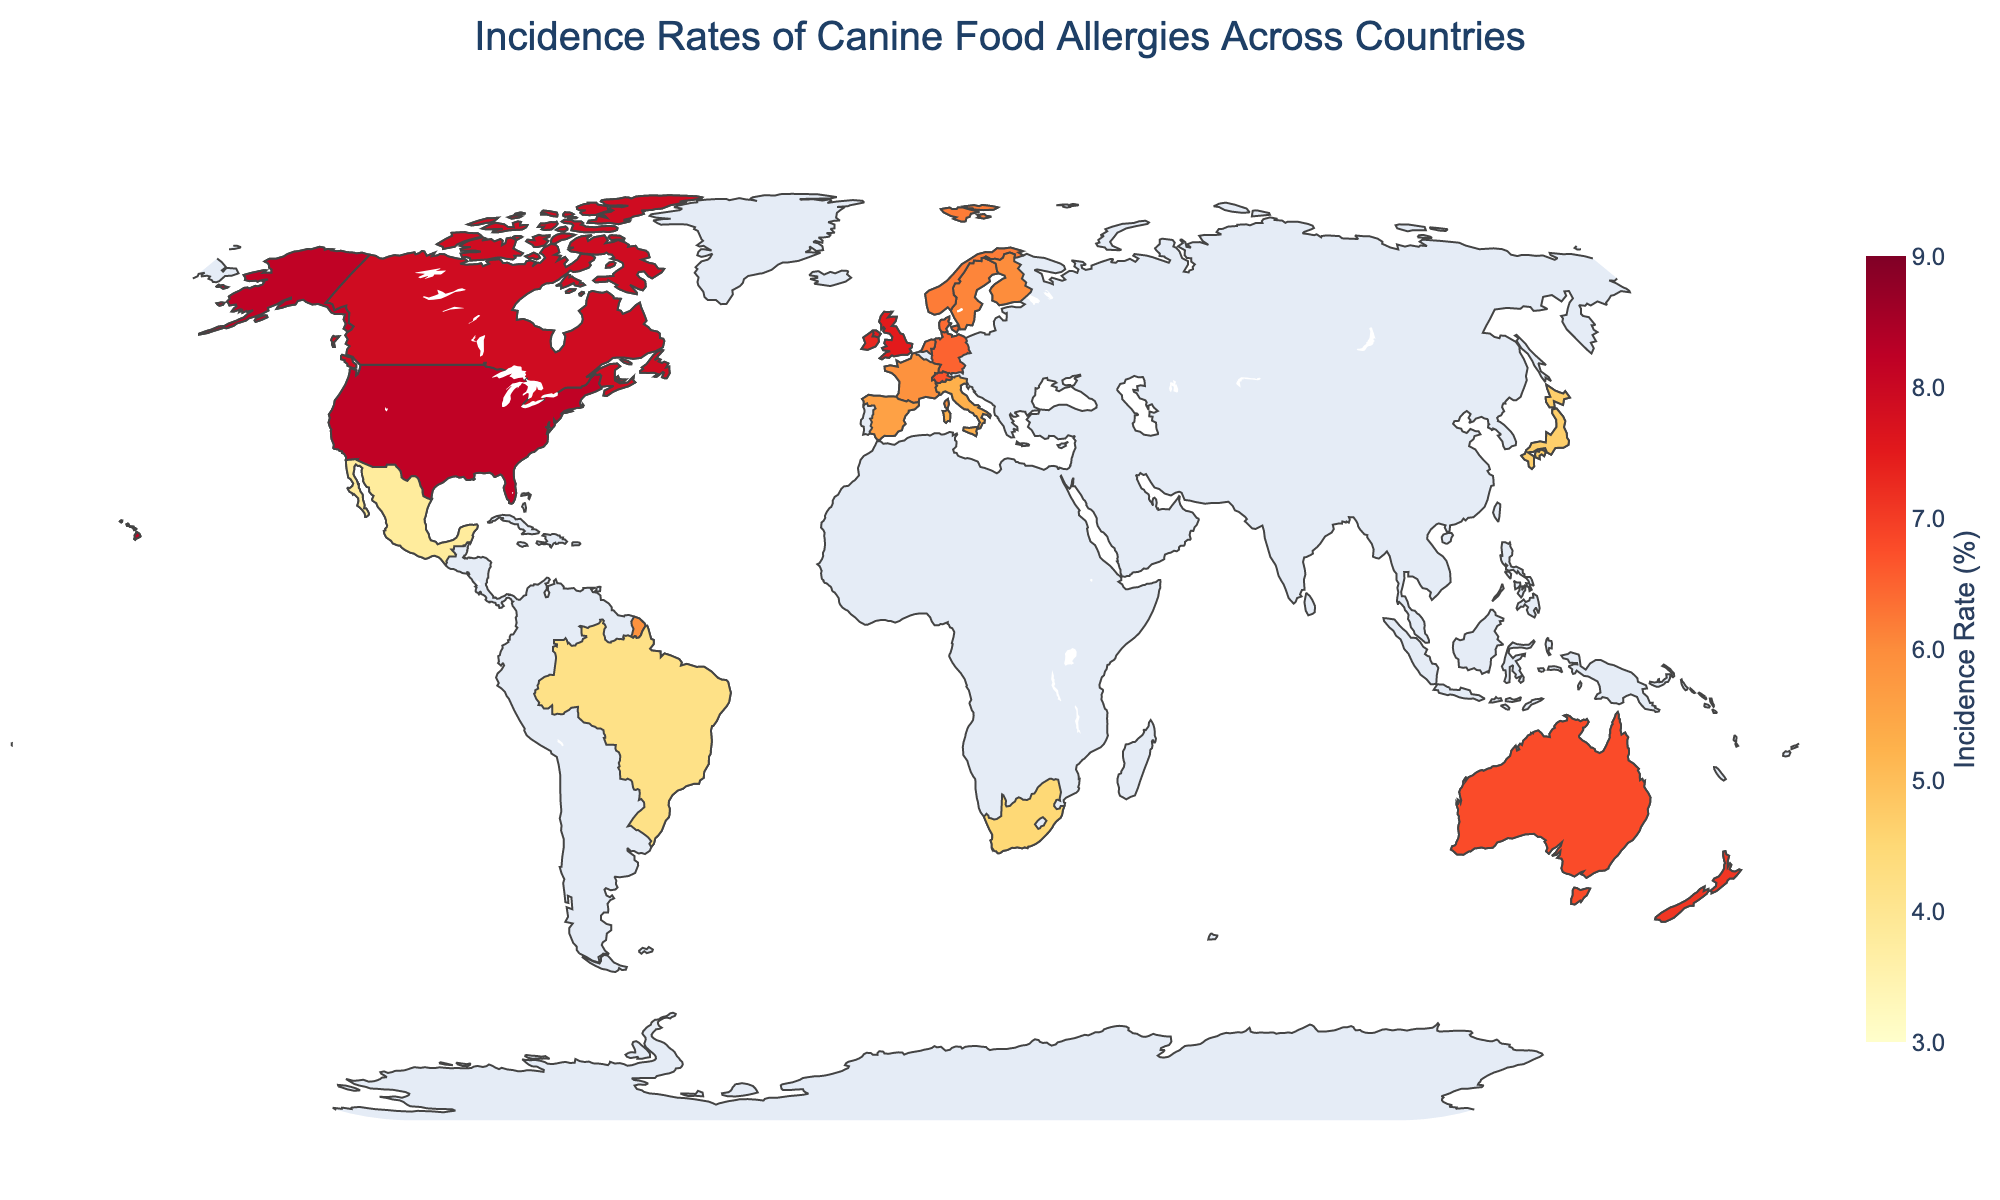What is the title of the plot? The plot title is usually displayed at the top of the figure, summarizing the main purpose or content.
Answer: Incidence Rates of Canine Food Allergies Across Countries Which country has the highest incidence rate of canine food allergies? To find the country with the highest incidence rate, look for the darkest color on the color scale, which represents the highest value.
Answer: United States What is the incidence rate of canine food allergies in Germany? Locate Germany on the map and refer to the color-coded scale or hover information to determine the incidence rate.
Answer: 6.5 How many countries have an incidence rate of 7.0 or higher? Count the number of countries that have an incidence rate equal to or higher than 7.0 based on the color scale or provided data through hover information.
Answer: 5 Which country has a lower incidence rate of canine food allergies, Brazil or Japan? Compare the colors or hover information of Brazil and Japan to determine which has a lower incidence rate.
Answer: Brazil What is the difference in incidence rates between Spain and Italy? Subtract the incidence rate of Italy from the incidence rate of Spain.
Answer: 0.3 What is the average incidence rate of canine food allergies for the countries listed? Add all the incidence rates together and divide by the number of countries.
Answer: 6.0 Which country in Europe has the lowest incidence rate of canine food allergies? Identify European countries on the map and determine which has the lightest color (lowest value).
Answer: France Compare the incidence rates of Canada and the United Kingdom. Which one is higher? Look at the colors or hover information for Canada and the United Kingdom and compare the incidence rates.
Answer: Canada Is the incidence rate of South Africa higher or lower than that of New Zealand? Compare the colors or hover information of South Africa and New Zealand to determine which has a higher or lower incidence rate.
Answer: Lower 